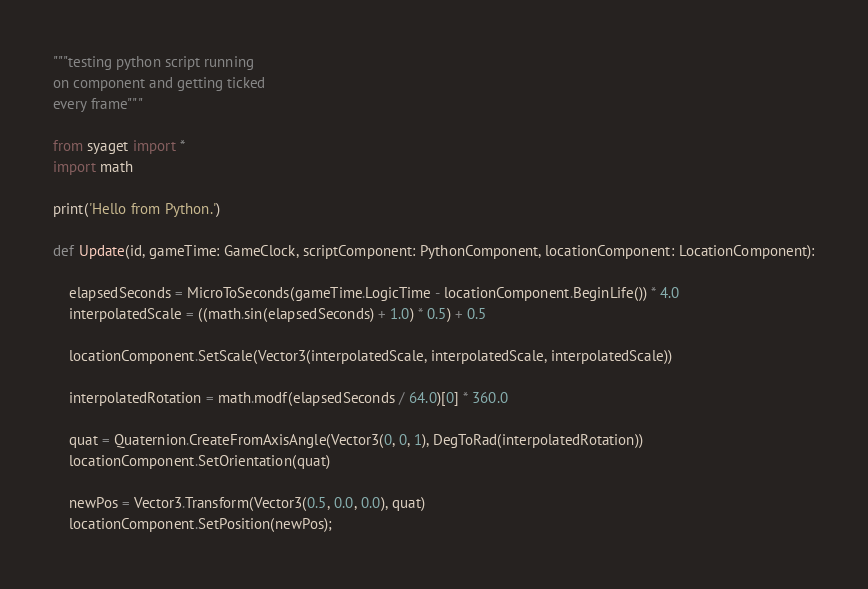Convert code to text. <code><loc_0><loc_0><loc_500><loc_500><_Python_>"""testing python script running
on component and getting ticked
every frame"""

from syaget import *
import math

print('Hello from Python.')

def Update(id, gameTime: GameClock, scriptComponent: PythonComponent, locationComponent: LocationComponent):

    elapsedSeconds = MicroToSeconds(gameTime.LogicTime - locationComponent.BeginLife()) * 4.0
    interpolatedScale = ((math.sin(elapsedSeconds) + 1.0) * 0.5) + 0.5

    locationComponent.SetScale(Vector3(interpolatedScale, interpolatedScale, interpolatedScale))

    interpolatedRotation = math.modf(elapsedSeconds / 64.0)[0] * 360.0

    quat = Quaternion.CreateFromAxisAngle(Vector3(0, 0, 1), DegToRad(interpolatedRotation))
    locationComponent.SetOrientation(quat)

    newPos = Vector3.Transform(Vector3(0.5, 0.0, 0.0), quat)
    locationComponent.SetPosition(newPos);
</code> 